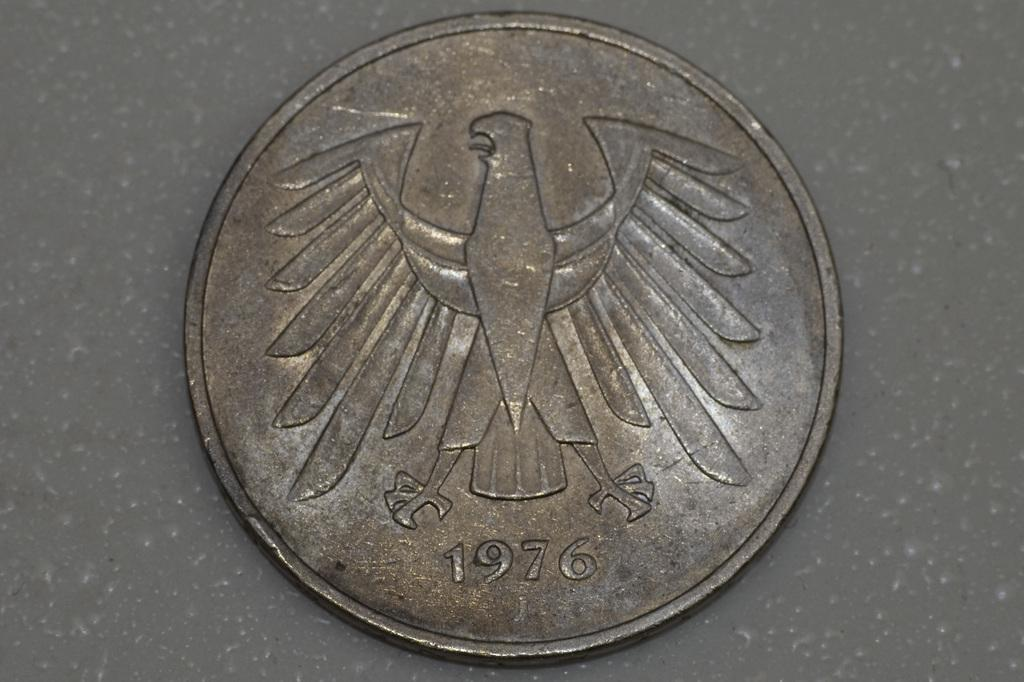<image>
Create a compact narrative representing the image presented. A coin that was minted in the year 1976. 